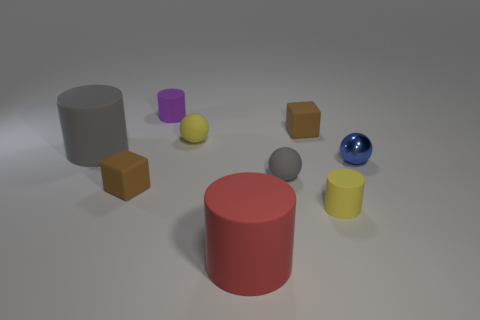What number of tiny brown rubber things are on the left side of the ball that is right of the small gray sphere?
Provide a succinct answer. 2. How many matte things are both left of the red thing and in front of the metal thing?
Ensure brevity in your answer.  1. How many things are either spheres or balls behind the small shiny thing?
Provide a succinct answer. 3. There is a yellow cylinder that is made of the same material as the small purple cylinder; what size is it?
Your answer should be very brief. Small. The yellow object that is behind the yellow thing in front of the large gray rubber object is what shape?
Your answer should be very brief. Sphere. How many yellow objects are small objects or tiny cubes?
Your response must be concise. 2. Is there a matte object that is in front of the tiny brown rubber cube behind the matte block in front of the small blue metal thing?
Offer a very short reply. Yes. Are there any other things that have the same material as the blue object?
Offer a terse response. No. How many big objects are either red metallic things or gray objects?
Provide a short and direct response. 1. There is a gray matte object that is to the left of the red cylinder; is it the same shape as the small purple rubber object?
Give a very brief answer. Yes. 